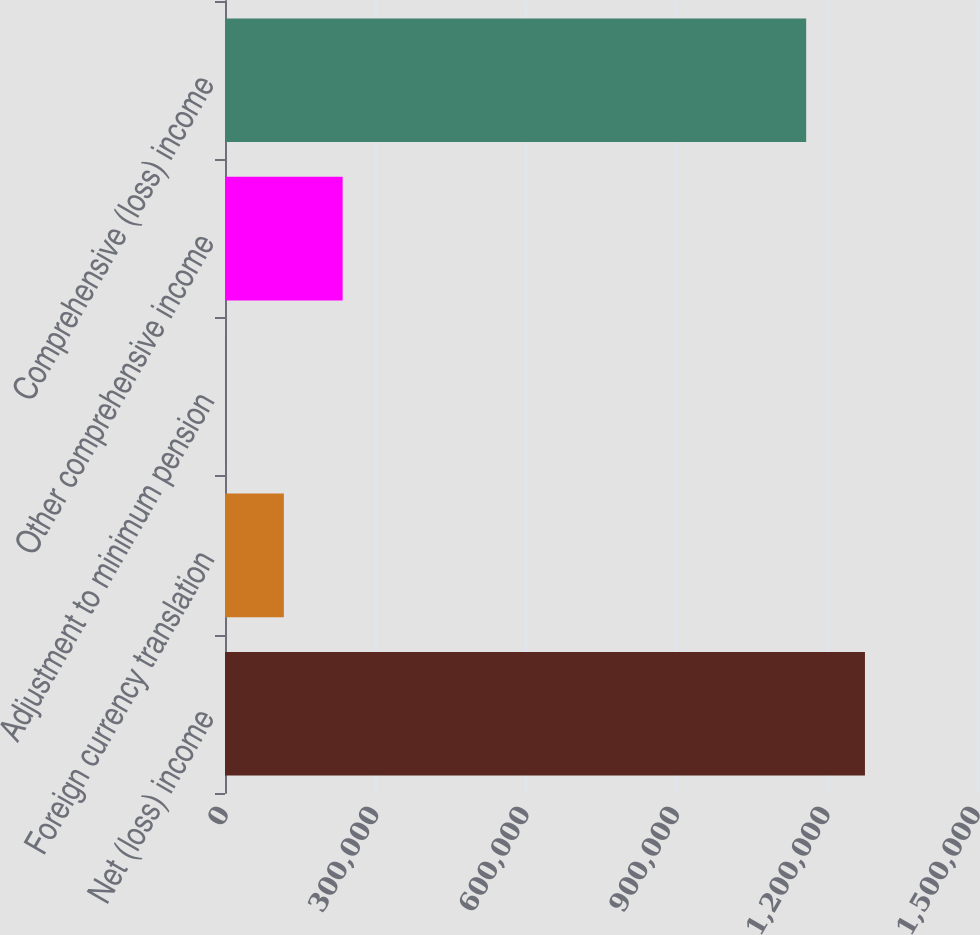<chart> <loc_0><loc_0><loc_500><loc_500><bar_chart><fcel>Net (loss) income<fcel>Foreign currency translation<fcel>Adjustment to minimum pension<fcel>Other comprehensive income<fcel>Comprehensive (loss) income<nl><fcel>1.27651e+06<fcel>117404<fcel>134<fcel>234675<fcel>1.15924e+06<nl></chart> 